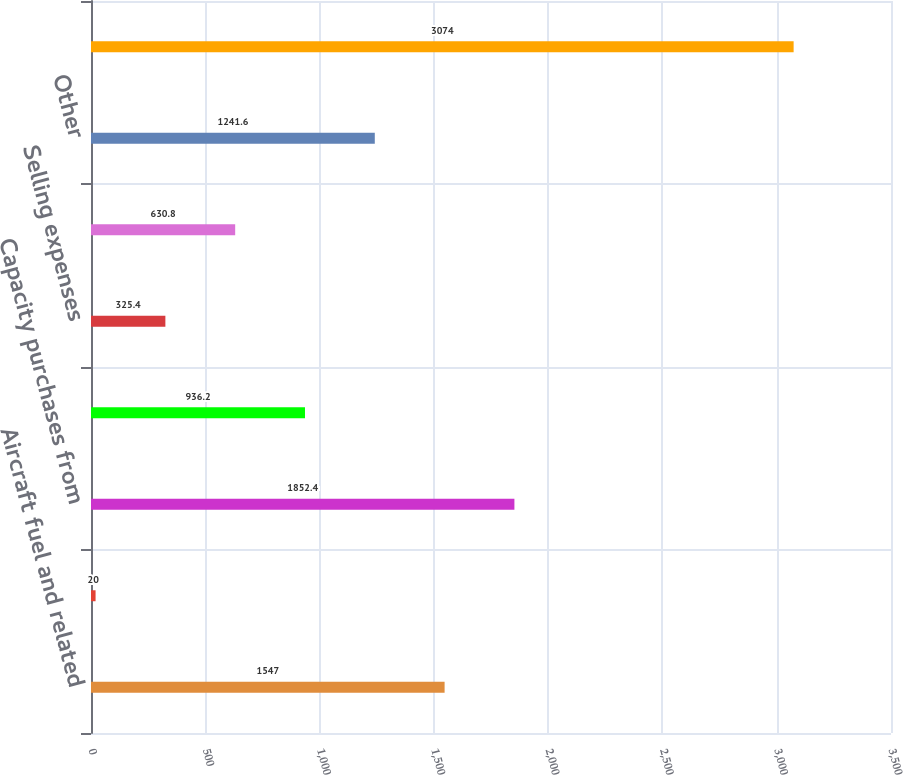Convert chart to OTSL. <chart><loc_0><loc_0><loc_500><loc_500><bar_chart><fcel>Aircraft fuel and related<fcel>Salaries wages and benefits<fcel>Capacity purchases from<fcel>Other rent and landing fees<fcel>Selling expenses<fcel>Depreciation and amortization<fcel>Other<fcel>Total regional expenses<nl><fcel>1547<fcel>20<fcel>1852.4<fcel>936.2<fcel>325.4<fcel>630.8<fcel>1241.6<fcel>3074<nl></chart> 